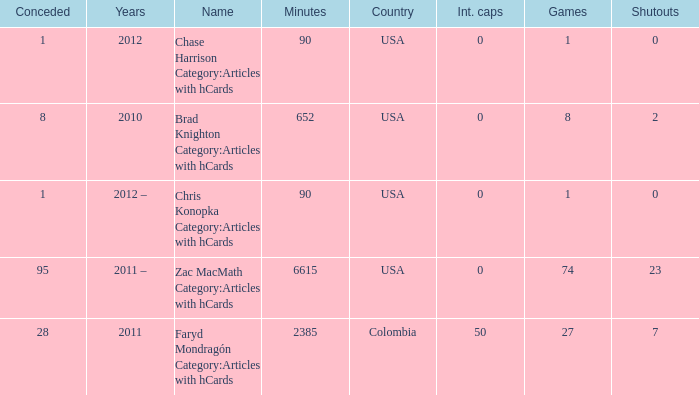What is the lowest overall amount of shutouts? 0.0. 